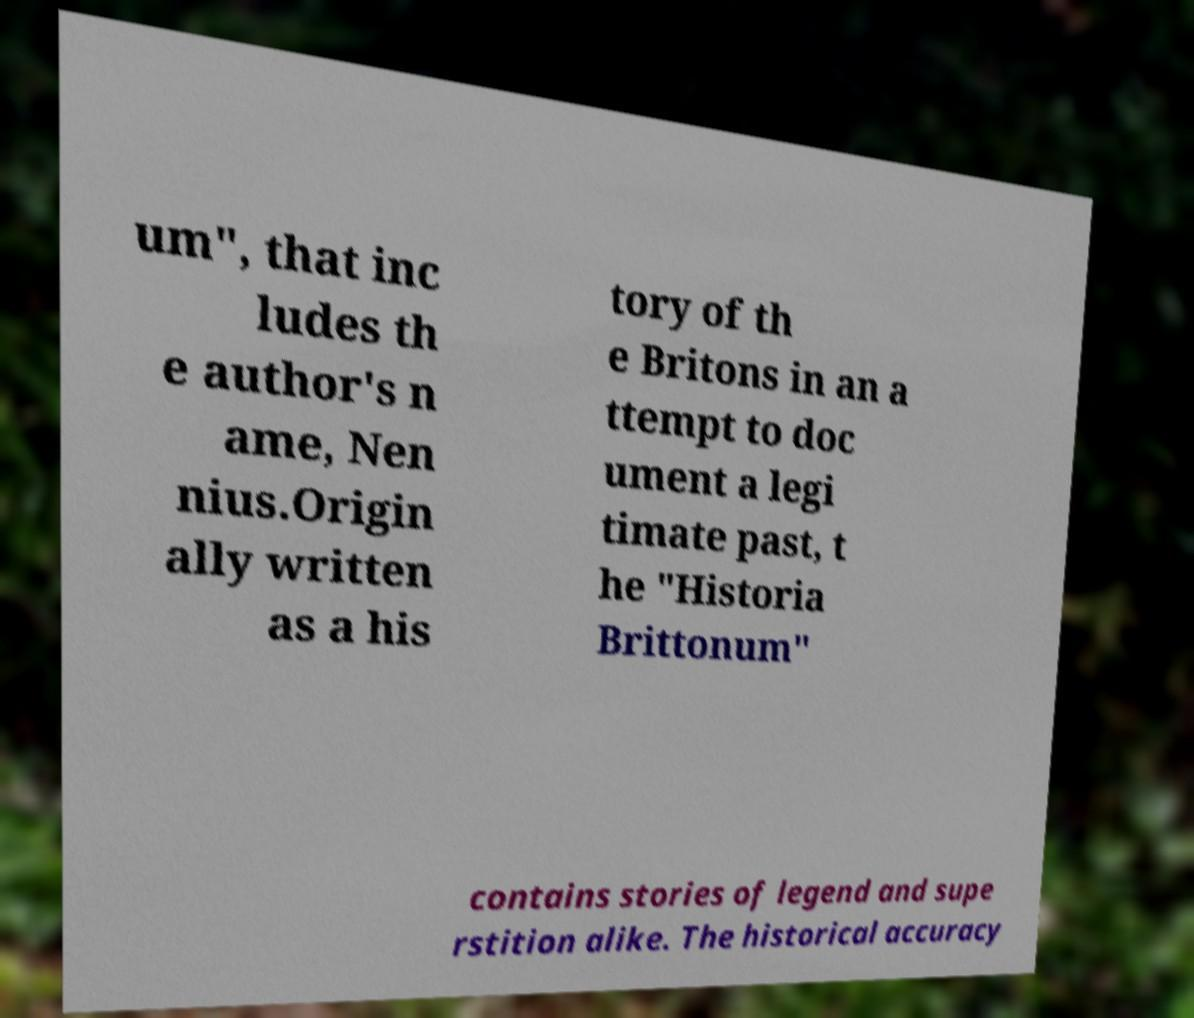Could you extract and type out the text from this image? um", that inc ludes th e author's n ame, Nen nius.Origin ally written as a his tory of th e Britons in an a ttempt to doc ument a legi timate past, t he "Historia Brittonum" contains stories of legend and supe rstition alike. The historical accuracy 